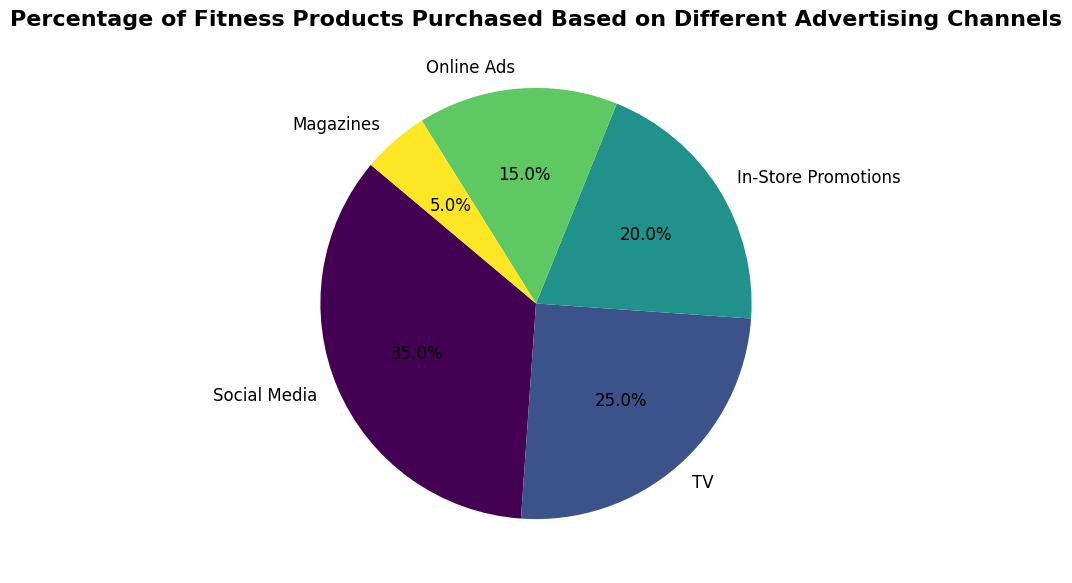What is the percentage of fitness products purchased through social media? Look for the section of the pie chart labeled "Social Media" and read the percentage within it.
Answer: 35% Which advertising channel leads to the least percentage of fitness products purchased? Identify the smallest section of the pie chart and read its label to determine the advertising channel.
Answer: Magazines What is the combined percentage of fitness products purchased through TV and In-Store Promotions? Locate the sections labeled "TV" and "In-Store Promotions" in the pie chart and add their percentages: 25% + 20% = 45%.
Answer: 45% Which advertising channel is responsible for a greater percentage of fitness products purchased: Online Ads or Magazines? Compare the sizes of the pie sections labeled "Online Ads" and "Magazines." Online Ads is 15%, and Magazines is 5%, so Online Ads has a greater percentage.
Answer: Online Ads Is the percentage of fitness products purchased through social media greater than the combined percentage of those purchased through TV and Magazines? Combine the percentages for TV (25%) and Magazines (5%) to get 30%, and compare it to the social media percentage (35%). Since 35% is greater than 30%, the answer is yes.
Answer: Yes Which two advertising channels have a combined percentage equal to that of social media? Look at the pie chart sections and compare combinations of their percentages to find which sum to 35%. TV (25%) and Magazines (5%) add to 30%, but In-Store Promotions (20%) and Online Ads (15%) add to 35%.
Answer: In-Store Promotions and Online Ads If the section representing TV was reduced by 5 percentage points, what would its new percentage be, and would it be greater than In-Store Promotions? Subtract 5 from TV's current percentage (25% - 5% = 20%) and compare the new value with In-Store Promotions (20%). The new value is equal to In-Store Promotions.
Answer: 20%, equal What is the average percentage of fitness products purchased through the five advertising channels? Add corresponding percentages (35% + 25% + 20% + 15% + 5%) and divide by the number of sections (5): (35% + 25% + 20% + 15% + 5%) / 5 = 20%.
Answer: 20% Which segment of the pie chart is the second largest, and what is its percentage? Identify the largest sections after Social Media (35%), which is TV, with a percentage of 25%. Compare percentages visually and numerically.
Answer: TV, 25% 